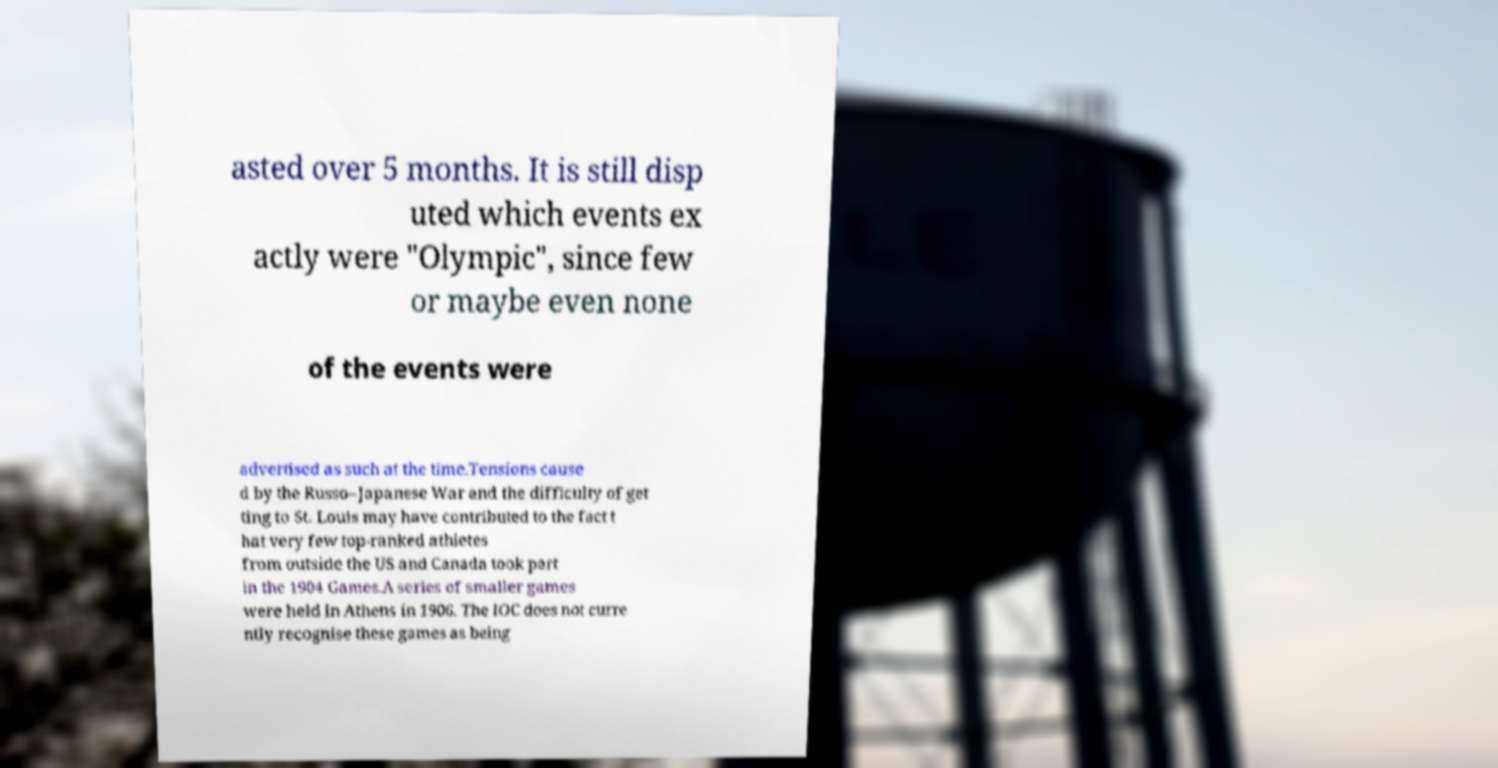What messages or text are displayed in this image? I need them in a readable, typed format. asted over 5 months. It is still disp uted which events ex actly were "Olympic", since few or maybe even none of the events were advertised as such at the time.Tensions cause d by the Russo–Japanese War and the difficulty of get ting to St. Louis may have contributed to the fact t hat very few top-ranked athletes from outside the US and Canada took part in the 1904 Games.A series of smaller games were held in Athens in 1906. The IOC does not curre ntly recognise these games as being 